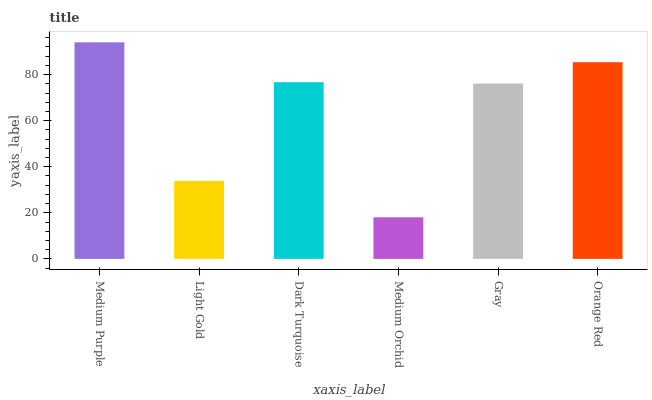Is Medium Orchid the minimum?
Answer yes or no. Yes. Is Medium Purple the maximum?
Answer yes or no. Yes. Is Light Gold the minimum?
Answer yes or no. No. Is Light Gold the maximum?
Answer yes or no. No. Is Medium Purple greater than Light Gold?
Answer yes or no. Yes. Is Light Gold less than Medium Purple?
Answer yes or no. Yes. Is Light Gold greater than Medium Purple?
Answer yes or no. No. Is Medium Purple less than Light Gold?
Answer yes or no. No. Is Dark Turquoise the high median?
Answer yes or no. Yes. Is Gray the low median?
Answer yes or no. Yes. Is Light Gold the high median?
Answer yes or no. No. Is Light Gold the low median?
Answer yes or no. No. 